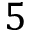Convert formula to latex. <formula><loc_0><loc_0><loc_500><loc_500>5</formula> 